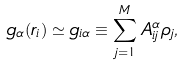Convert formula to latex. <formula><loc_0><loc_0><loc_500><loc_500>g _ { \alpha } ( { r } _ { i } ) \simeq g _ { i \alpha } \equiv \sum _ { j = 1 } ^ { M } A _ { i j } ^ { \alpha } \rho _ { j } ,</formula> 